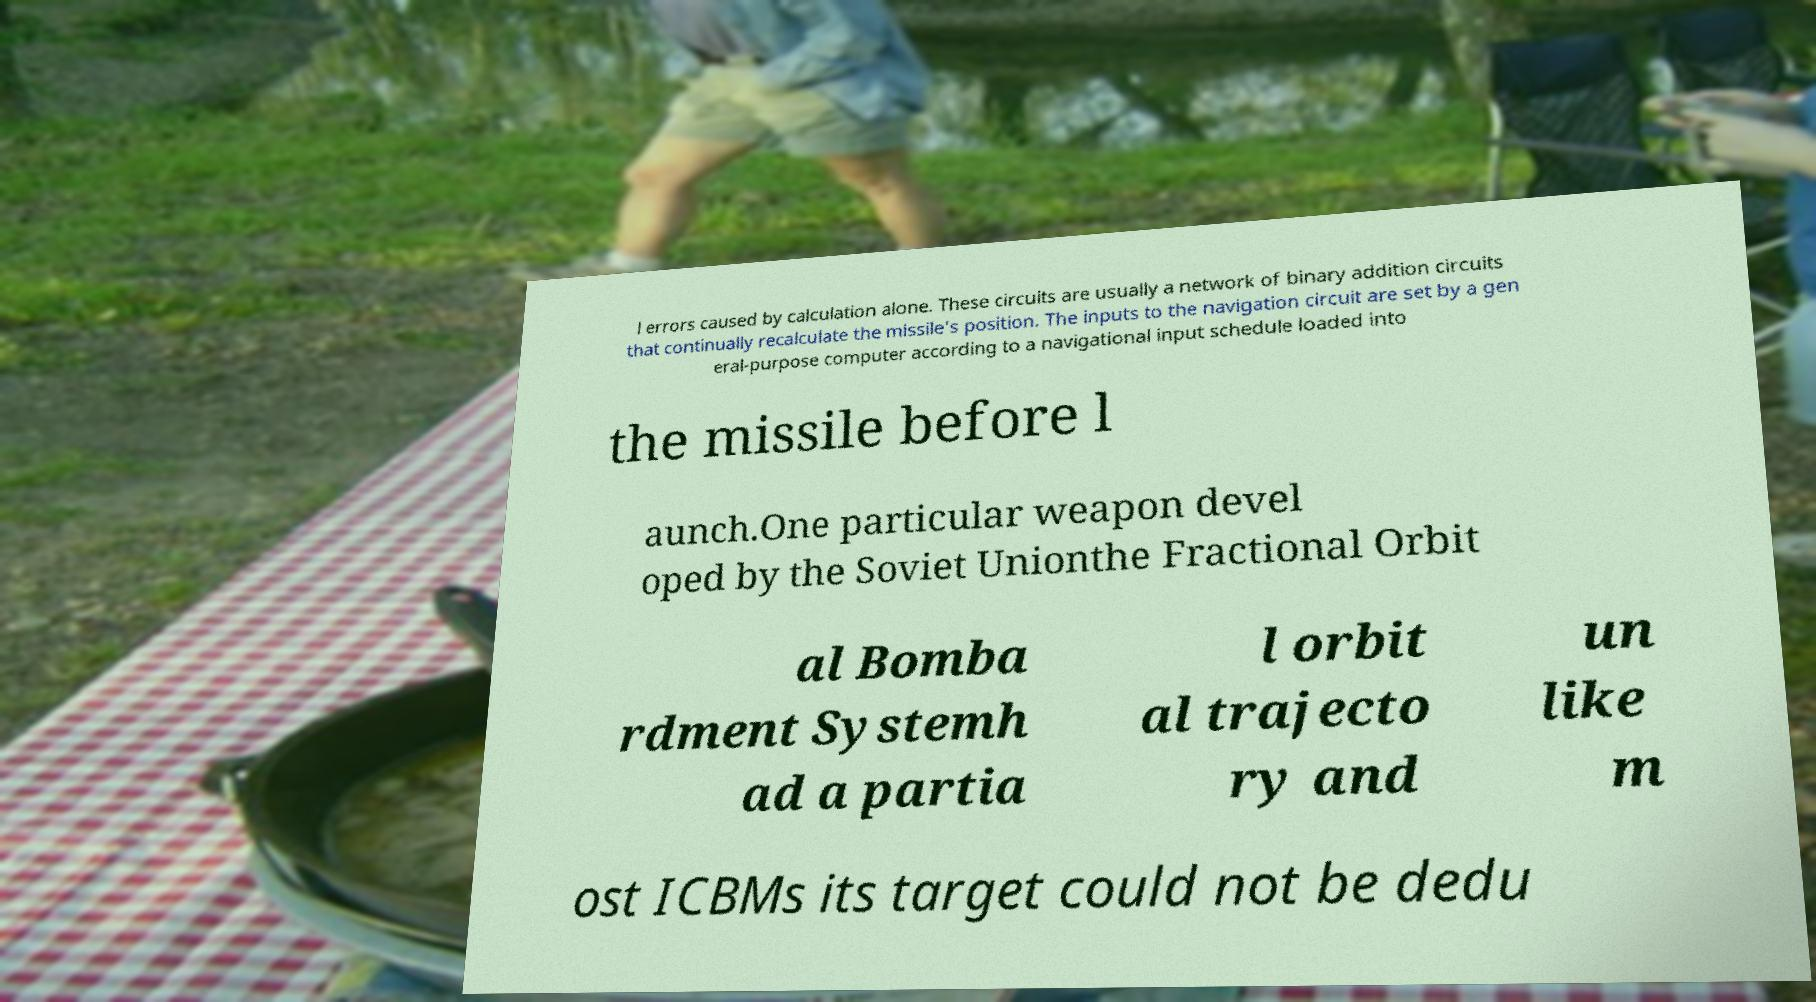Could you extract and type out the text from this image? l errors caused by calculation alone. These circuits are usually a network of binary addition circuits that continually recalculate the missile's position. The inputs to the navigation circuit are set by a gen eral-purpose computer according to a navigational input schedule loaded into the missile before l aunch.One particular weapon devel oped by the Soviet Unionthe Fractional Orbit al Bomba rdment Systemh ad a partia l orbit al trajecto ry and un like m ost ICBMs its target could not be dedu 